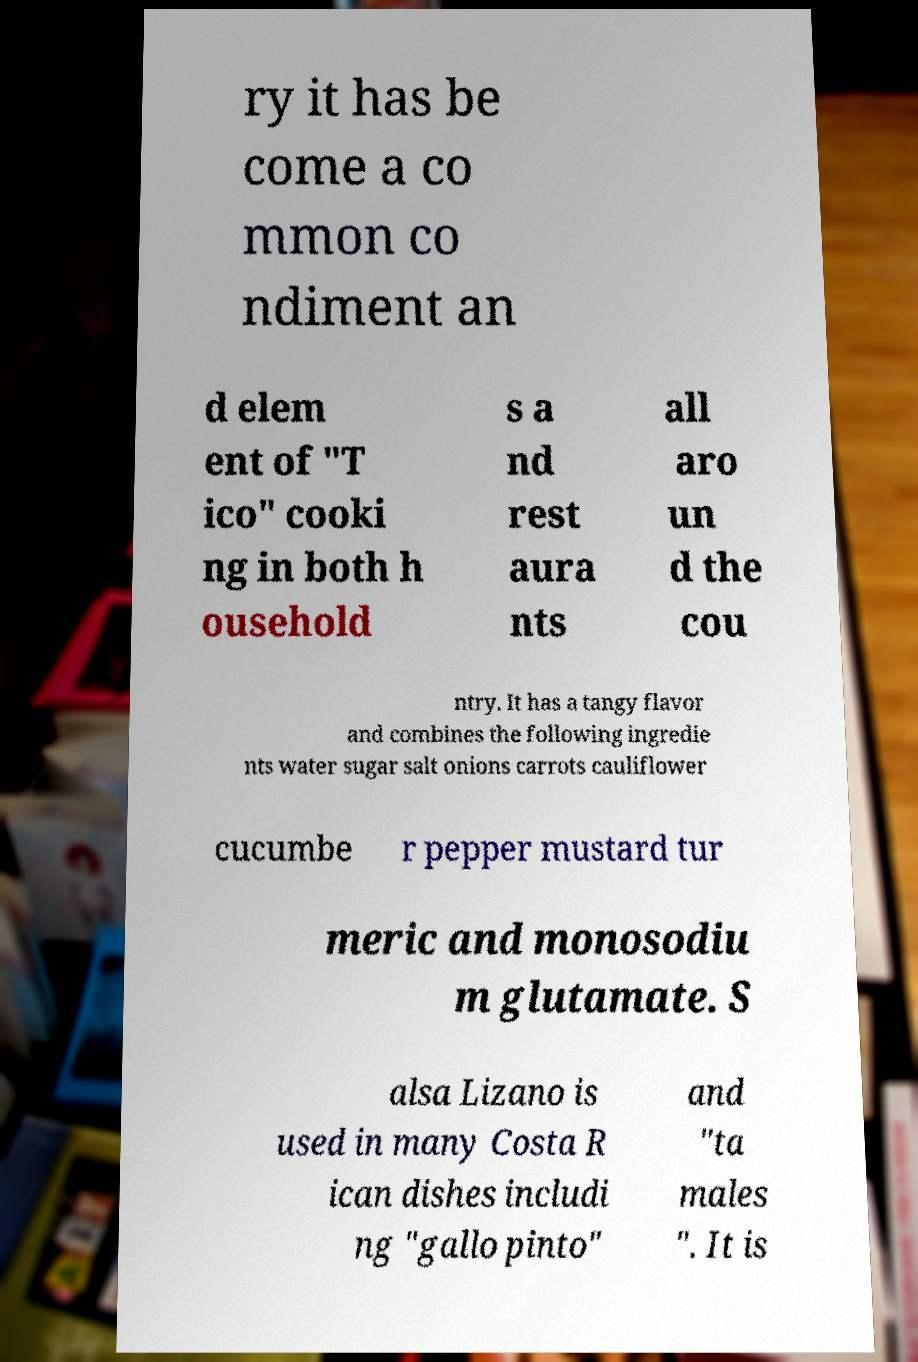For documentation purposes, I need the text within this image transcribed. Could you provide that? ry it has be come a co mmon co ndiment an d elem ent of "T ico" cooki ng in both h ousehold s a nd rest aura nts all aro un d the cou ntry. It has a tangy flavor and combines the following ingredie nts water sugar salt onions carrots cauliflower cucumbe r pepper mustard tur meric and monosodiu m glutamate. S alsa Lizano is used in many Costa R ican dishes includi ng "gallo pinto" and "ta males ". It is 